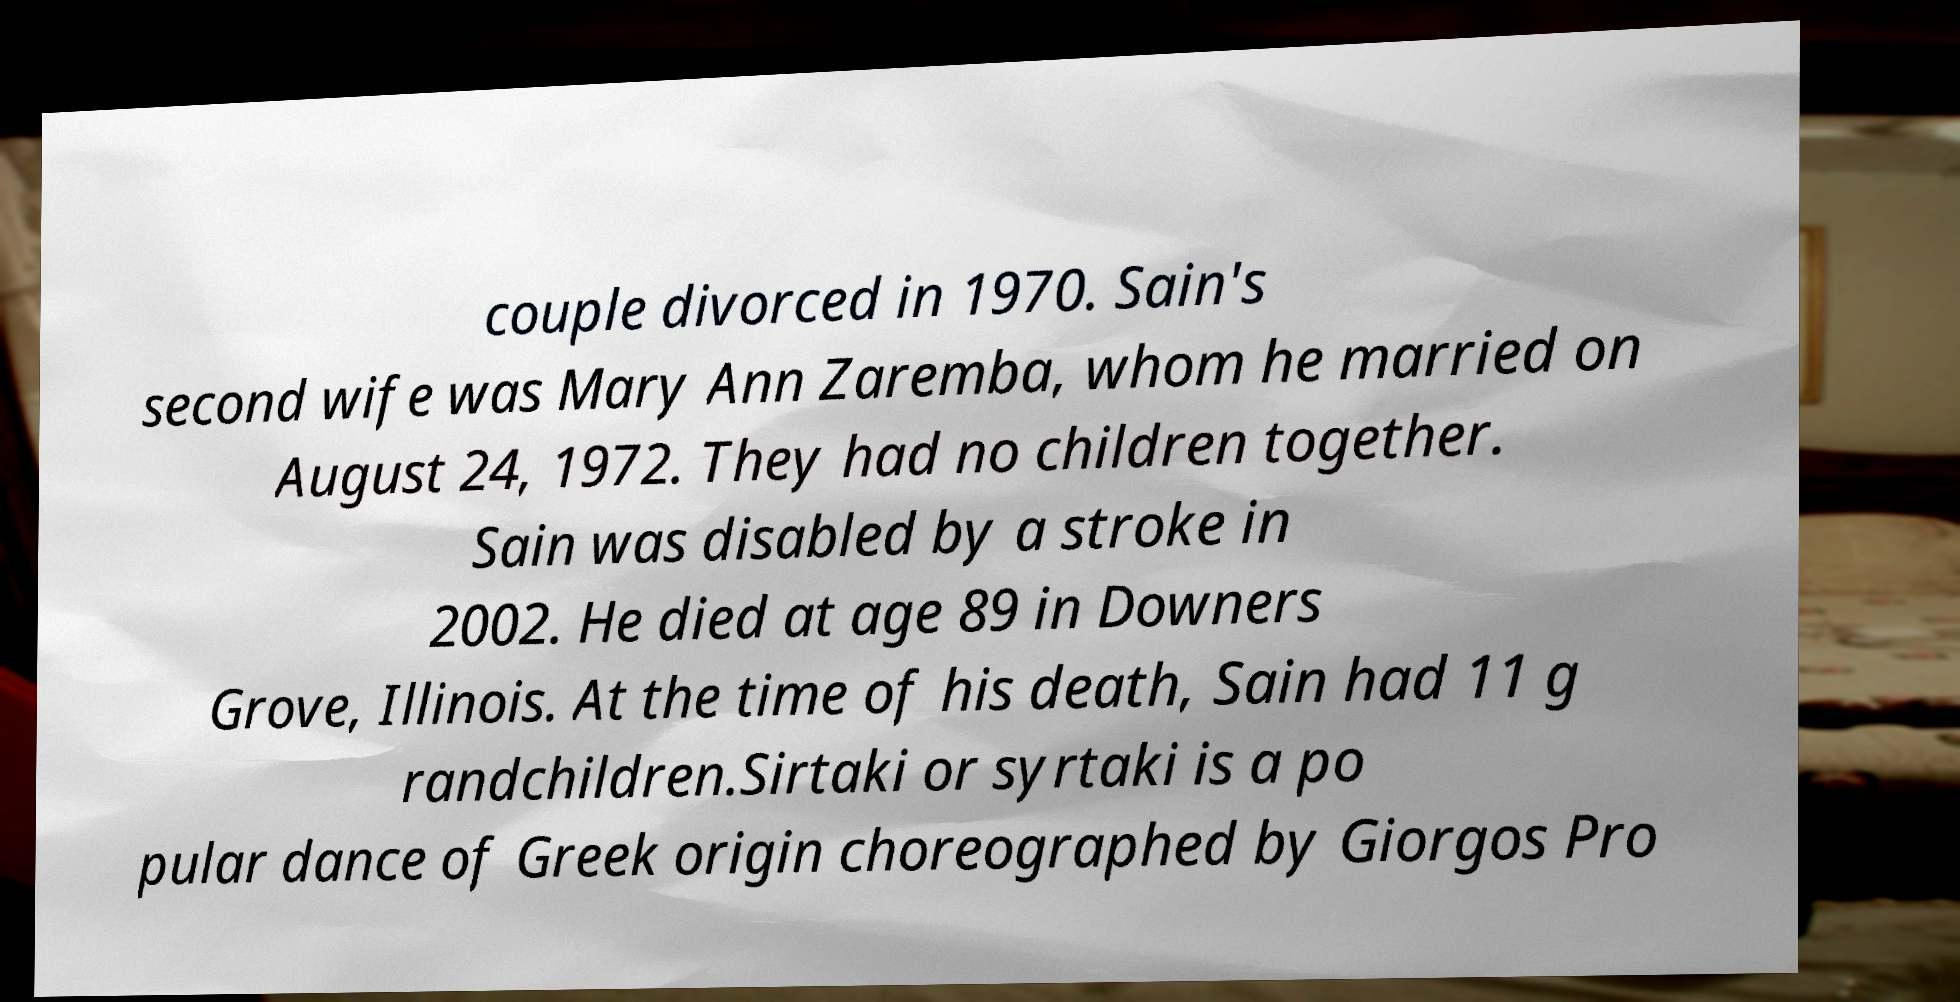Please read and relay the text visible in this image. What does it say? couple divorced in 1970. Sain's second wife was Mary Ann Zaremba, whom he married on August 24, 1972. They had no children together. Sain was disabled by a stroke in 2002. He died at age 89 in Downers Grove, Illinois. At the time of his death, Sain had 11 g randchildren.Sirtaki or syrtaki is a po pular dance of Greek origin choreographed by Giorgos Pro 